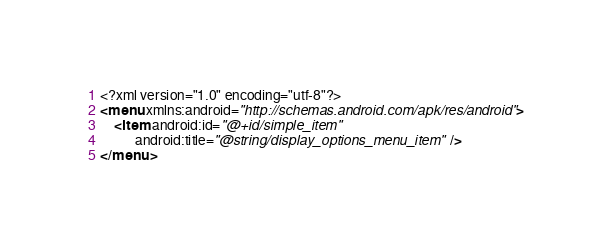Convert code to text. <code><loc_0><loc_0><loc_500><loc_500><_XML_><?xml version="1.0" encoding="utf-8"?>
<menu xmlns:android="http://schemas.android.com/apk/res/android">
    <item android:id="@+id/simple_item"
          android:title="@string/display_options_menu_item" />
</menu>
</code> 